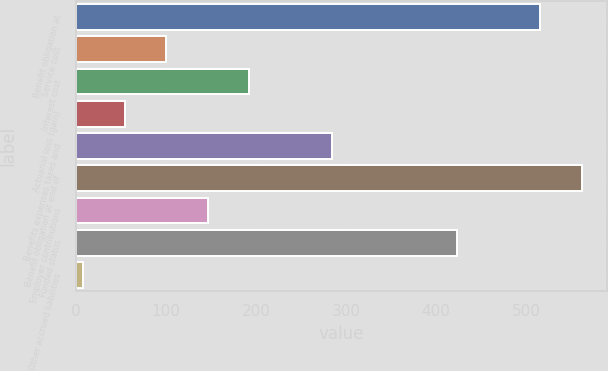Convert chart. <chart><loc_0><loc_0><loc_500><loc_500><bar_chart><fcel>Benefit obligation at<fcel>Service cost<fcel>Interest cost<fcel>Actuarial loss (gain)<fcel>Benefits expenses taxes and<fcel>Benefit obligation at end of<fcel>Employer contributions<fcel>Funded status<fcel>Other accrued liabilities<nl><fcel>515.8<fcel>100<fcel>192.4<fcel>53.8<fcel>284.8<fcel>562<fcel>146.2<fcel>423.4<fcel>7.6<nl></chart> 